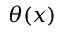<formula> <loc_0><loc_0><loc_500><loc_500>\theta ( x )</formula> 